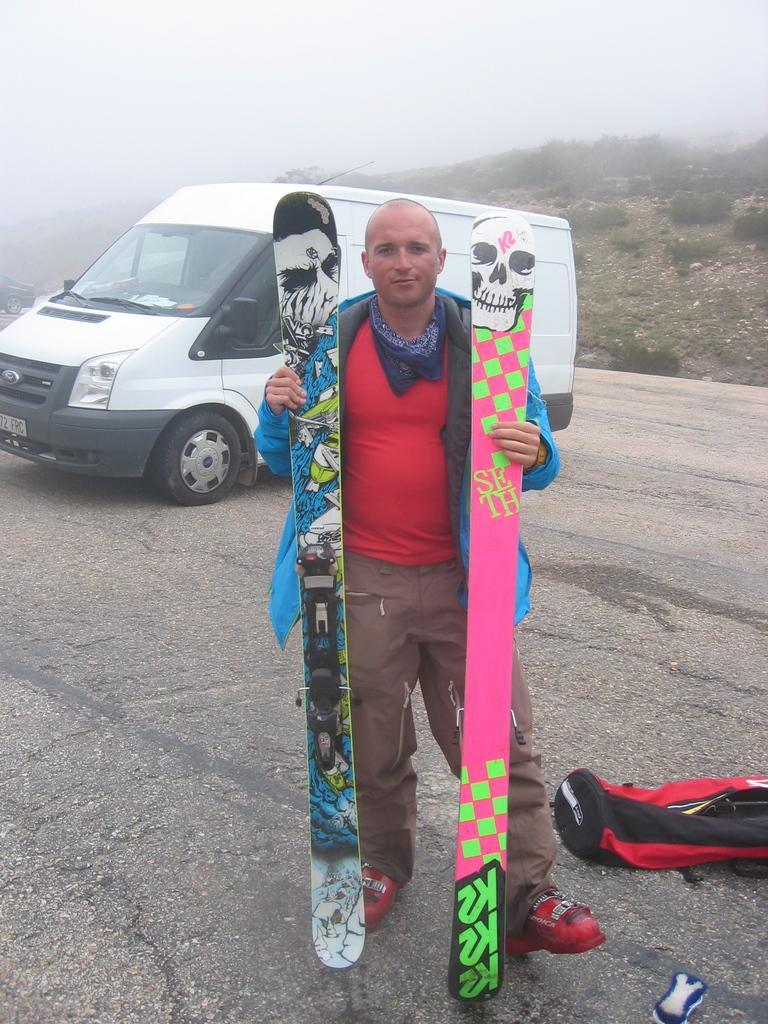Please provide a concise description of this image. In the middle of the image a man is standing and holding skies. Behind him there is a vehicle. Behind the vehicle there are some vehicles and hills and trees. At the top of the image there is sky. In the bottom right corner of the image there is a bag. 